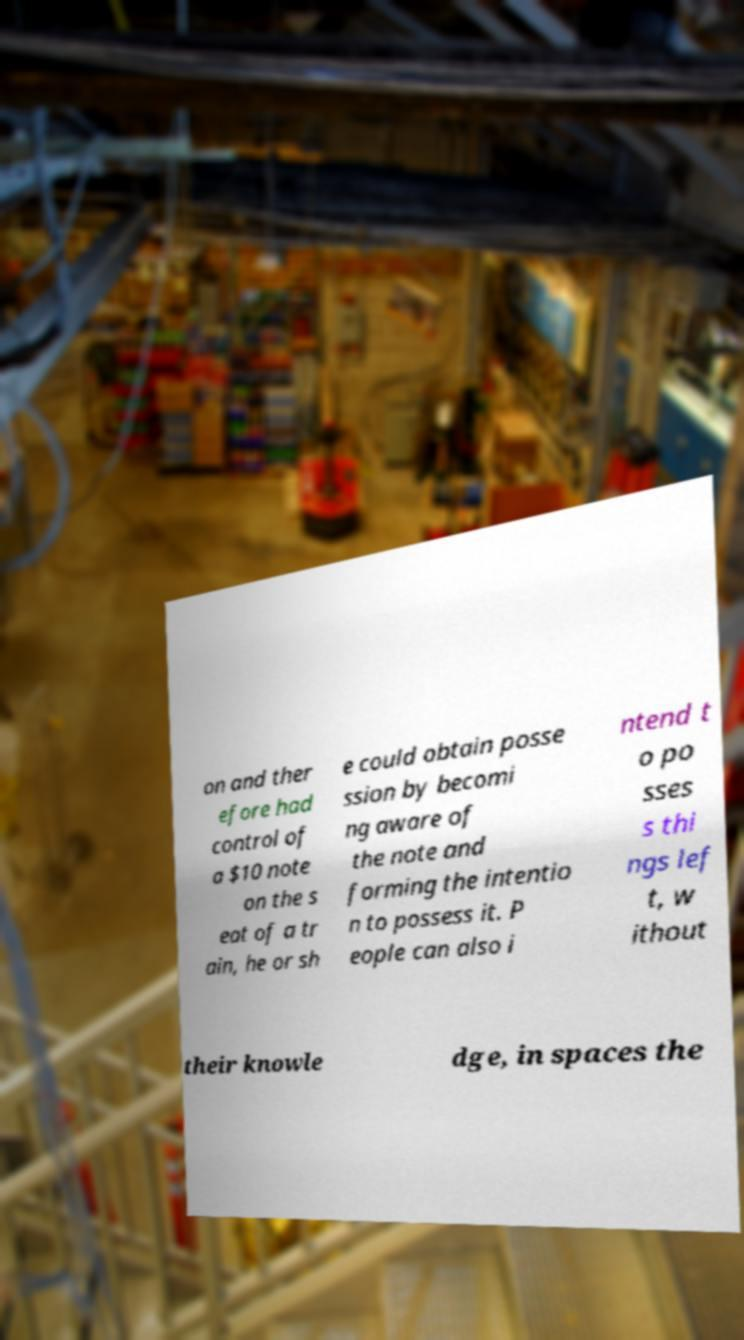Please read and relay the text visible in this image. What does it say? on and ther efore had control of a $10 note on the s eat of a tr ain, he or sh e could obtain posse ssion by becomi ng aware of the note and forming the intentio n to possess it. P eople can also i ntend t o po sses s thi ngs lef t, w ithout their knowle dge, in spaces the 